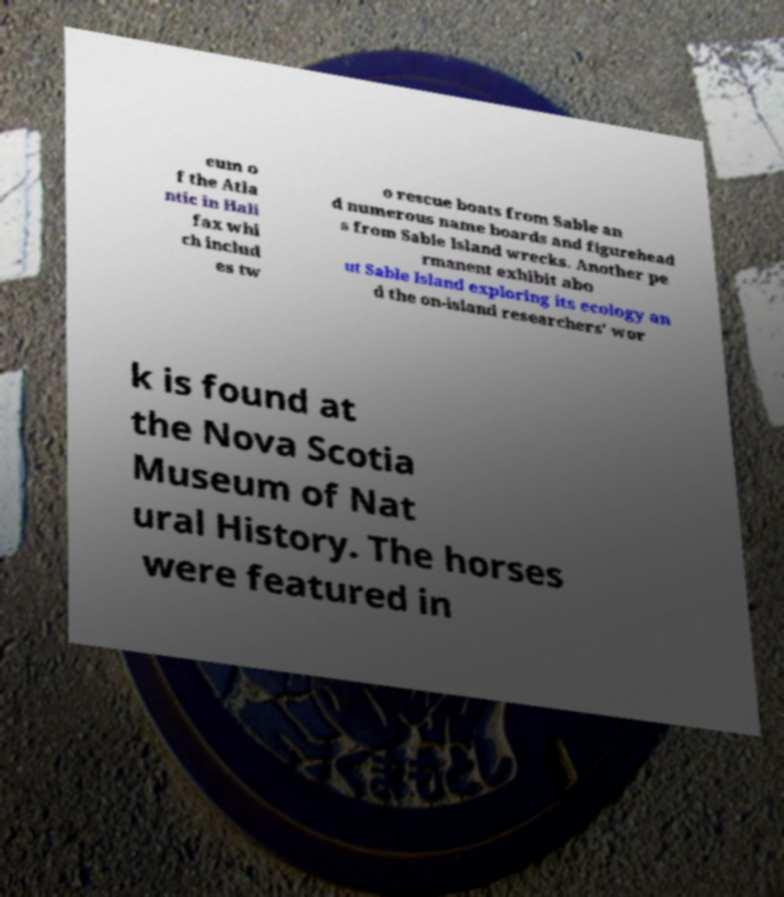Could you assist in decoding the text presented in this image and type it out clearly? eum o f the Atla ntic in Hali fax whi ch includ es tw o rescue boats from Sable an d numerous name boards and figurehead s from Sable Island wrecks. Another pe rmanent exhibit abo ut Sable Island exploring its ecology an d the on-island researchers' wor k is found at the Nova Scotia Museum of Nat ural History. The horses were featured in 